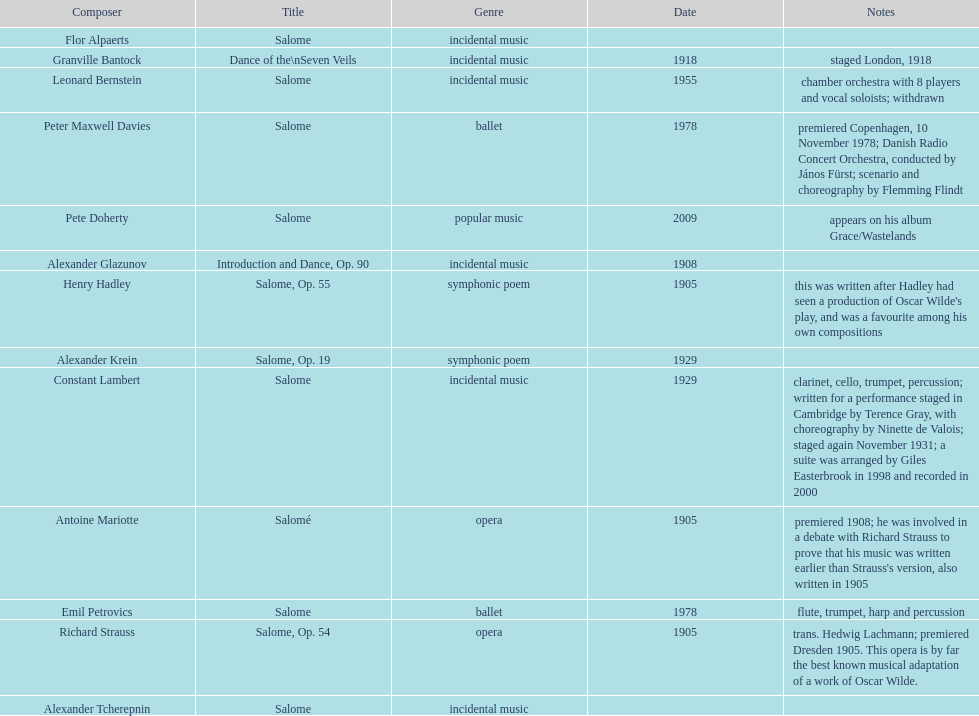Which composer created their work after 2001? Pete Doherty. 